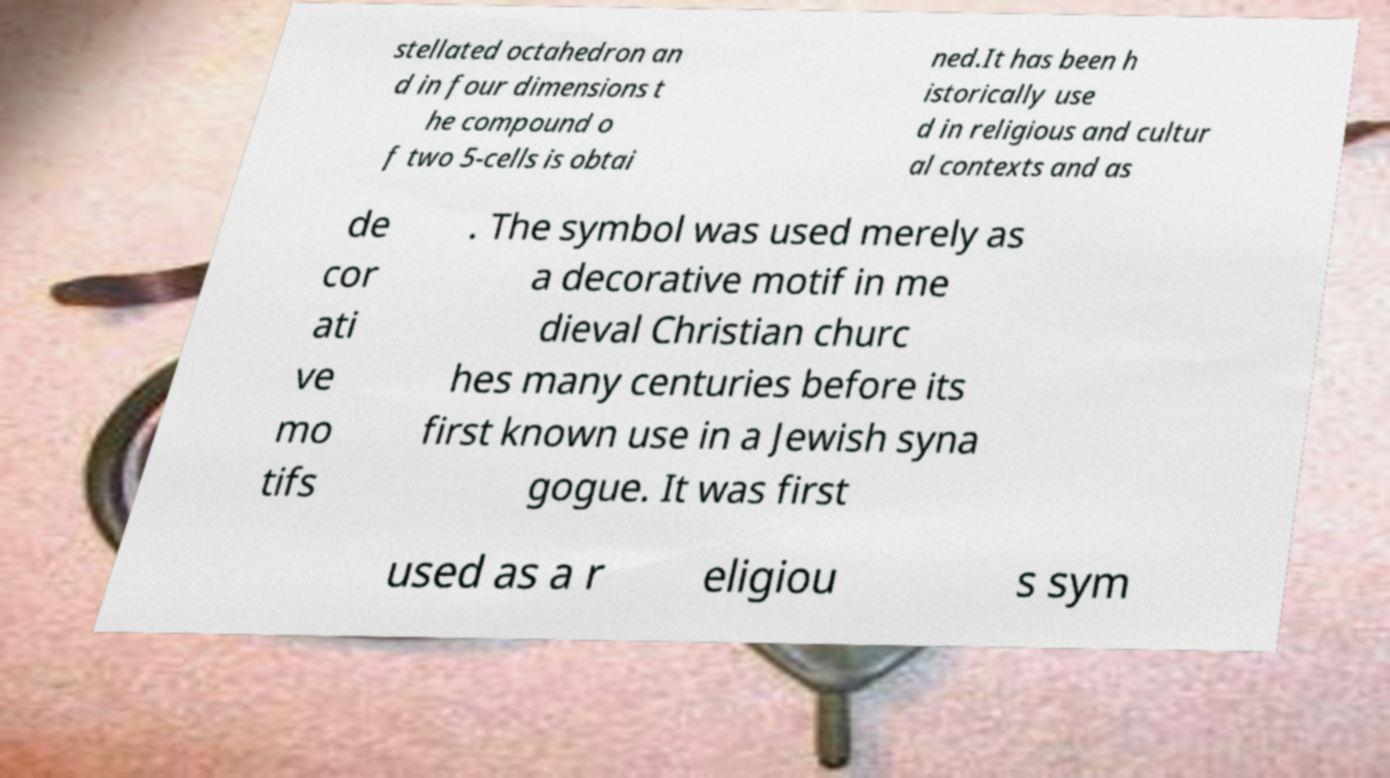Could you extract and type out the text from this image? stellated octahedron an d in four dimensions t he compound o f two 5-cells is obtai ned.It has been h istorically use d in religious and cultur al contexts and as de cor ati ve mo tifs . The symbol was used merely as a decorative motif in me dieval Christian churc hes many centuries before its first known use in a Jewish syna gogue. It was first used as a r eligiou s sym 